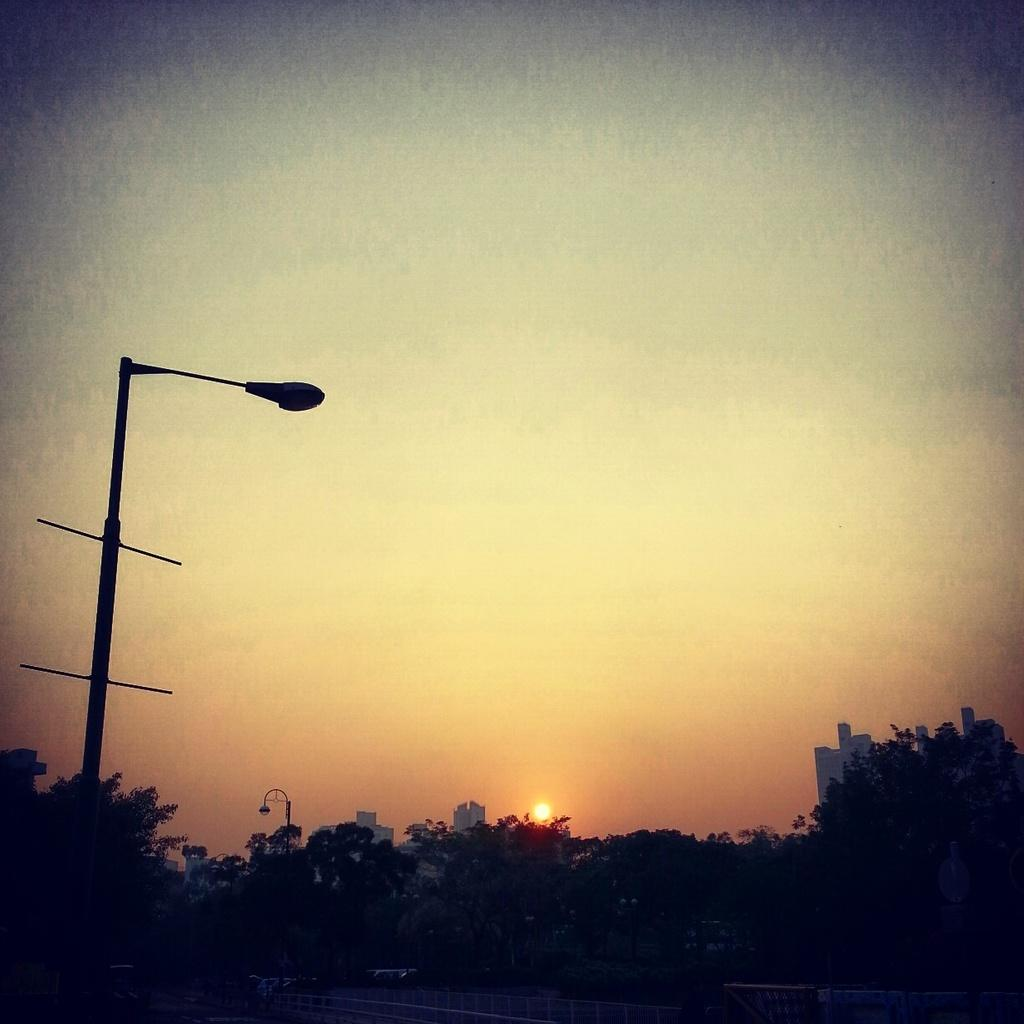What type of natural elements can be seen in the image? There are trees in the image. What type of artificial lighting is present in the image? There are lights on poles in the image. What type of man-made structures can be seen in the background of the image? There are buildings in the background of the image. What is visible in the sky in the image? The sky is visible in the background of the image, and the sun is observable. What type of cream is being used to treat the cough in the image? There is no mention of cream or cough in the image; it features trees, lights on poles, buildings, and the sky. 